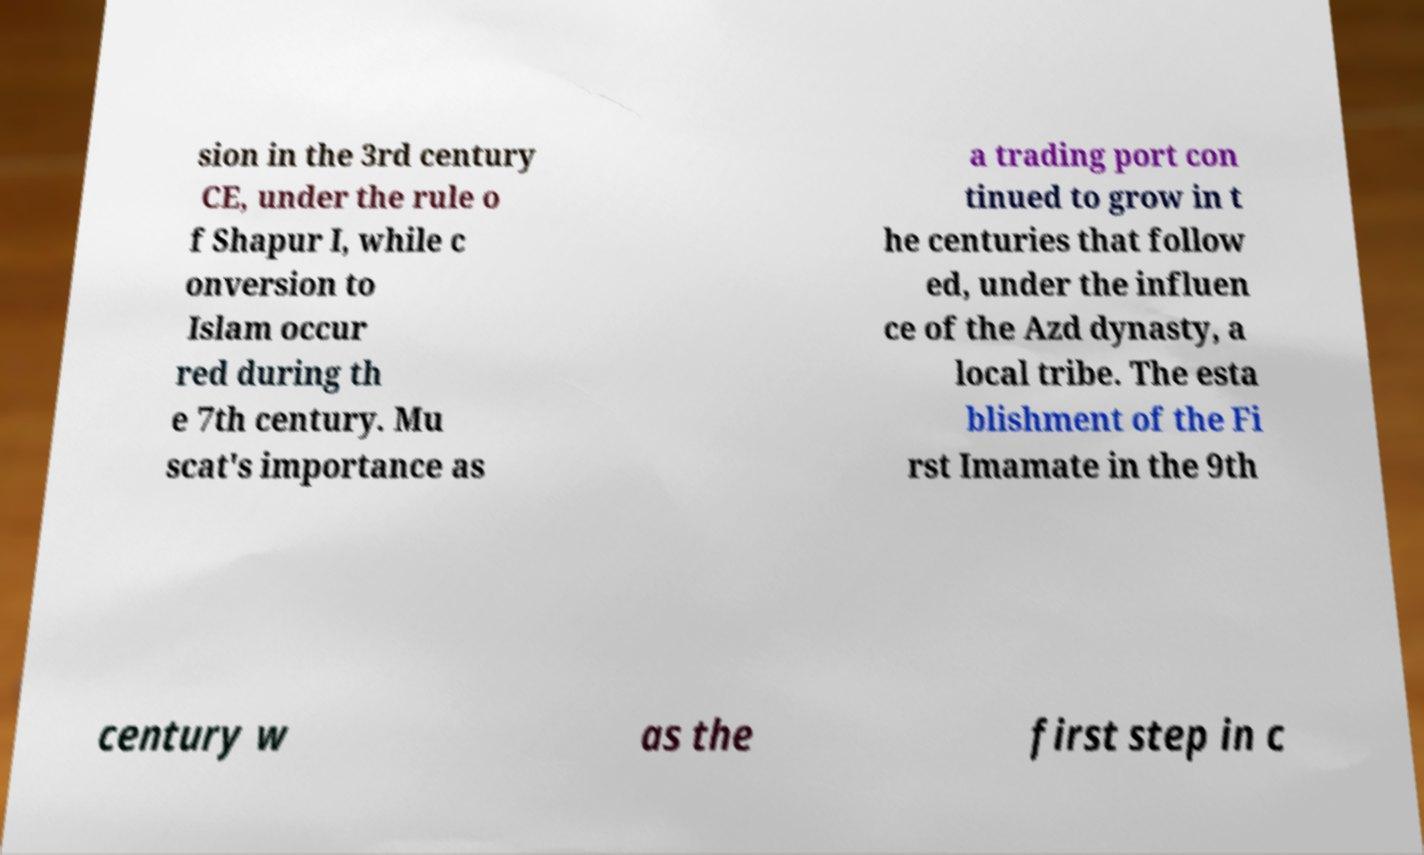For documentation purposes, I need the text within this image transcribed. Could you provide that? sion in the 3rd century CE, under the rule o f Shapur I, while c onversion to Islam occur red during th e 7th century. Mu scat's importance as a trading port con tinued to grow in t he centuries that follow ed, under the influen ce of the Azd dynasty, a local tribe. The esta blishment of the Fi rst Imamate in the 9th century w as the first step in c 